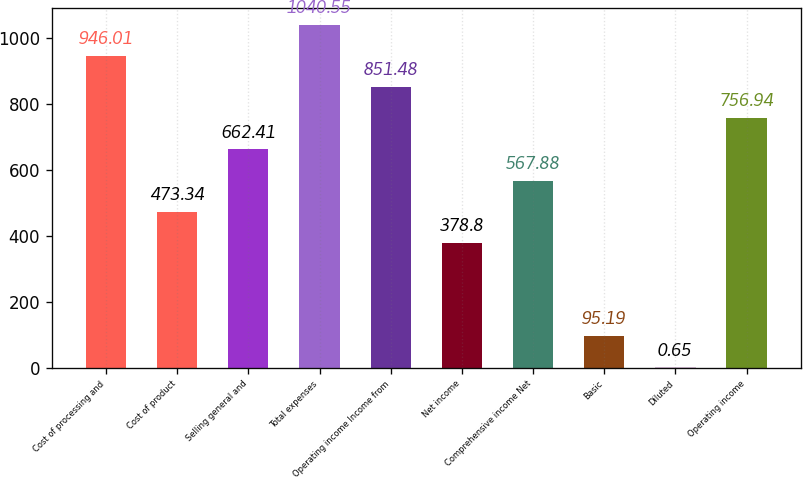<chart> <loc_0><loc_0><loc_500><loc_500><bar_chart><fcel>Cost of processing and<fcel>Cost of product<fcel>Selling general and<fcel>Total expenses<fcel>Operating income Income from<fcel>Net income<fcel>Comprehensive income Net<fcel>Basic<fcel>Diluted<fcel>Operating income<nl><fcel>946.01<fcel>473.34<fcel>662.41<fcel>1040.55<fcel>851.48<fcel>378.8<fcel>567.88<fcel>95.19<fcel>0.65<fcel>756.94<nl></chart> 